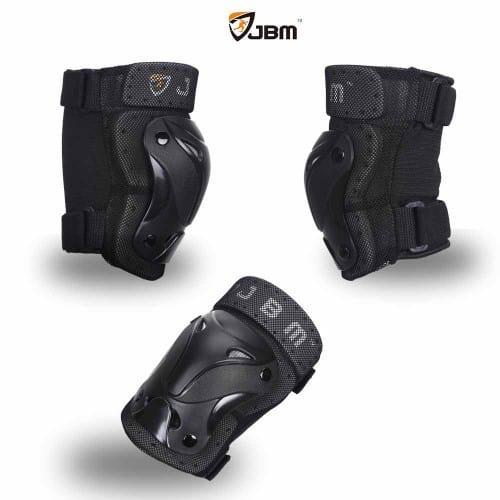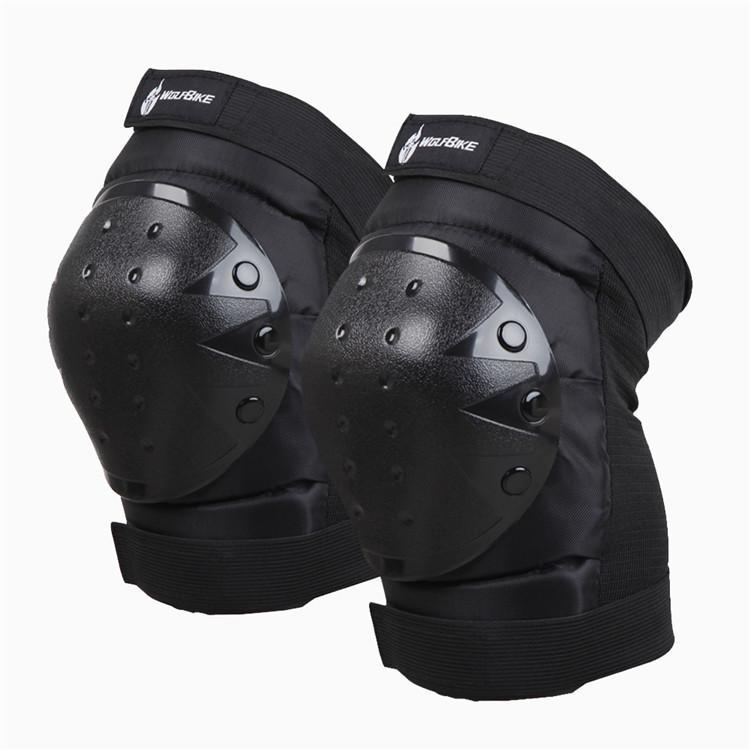The first image is the image on the left, the second image is the image on the right. Assess this claim about the two images: "An image shows exactly three pads, which are not arranged in one horizontal row.". Correct or not? Answer yes or no. Yes. The first image is the image on the left, the second image is the image on the right. Given the left and right images, does the statement "There is a red marking on at least one of the knee pads in the image on the right side." hold true? Answer yes or no. No. 